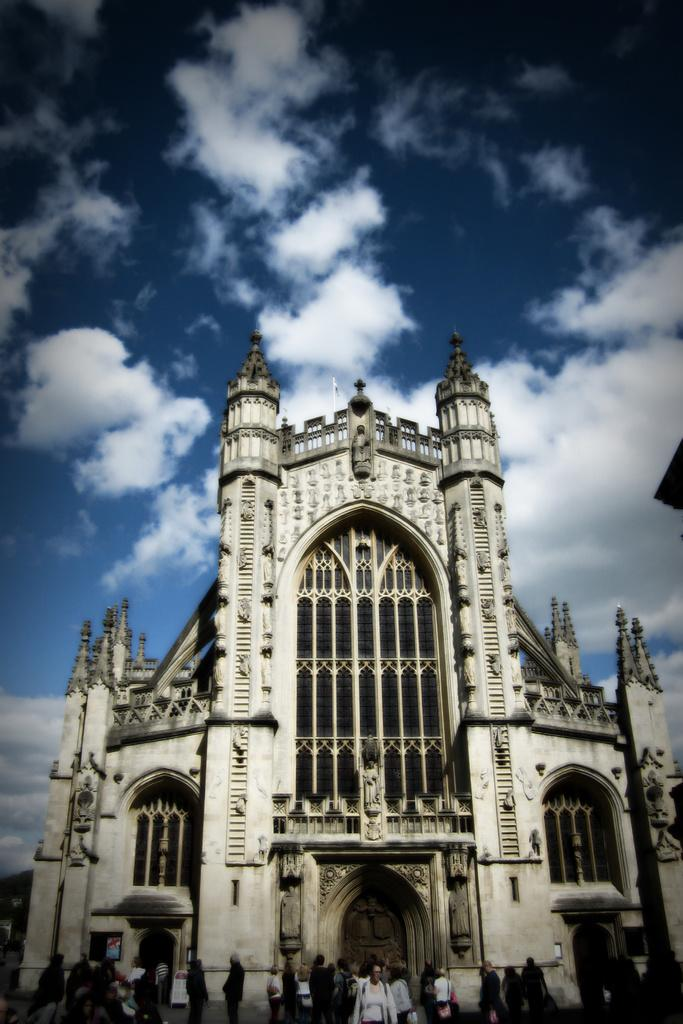What are the people in the image doing? The people in the image are standing on a path. What can be seen in the background of the image? There is a building and the sky visible in the background of the image. What type of drink is being offered by the ghost in the image? There is no ghost present in the image, and therefore no drink is being offered. 